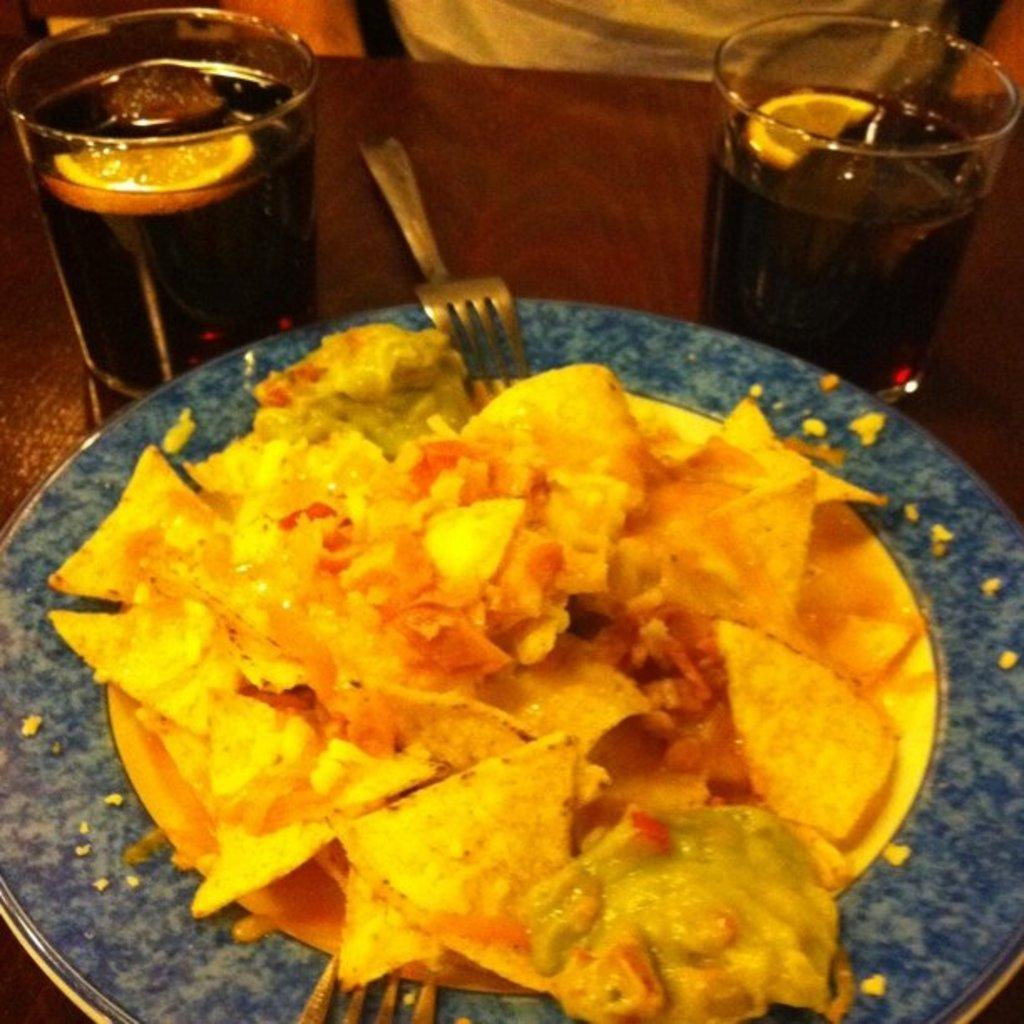What piece of furniture is present in the image? There is a table in the image. What is placed on the table? There is a plate of food on the table. What utensils are available on the table? There are forks, spoons, and knives on the table. What type of beverages are on the table? There are glasses of cool drinks on the table. How does the cook wave at the guests in the image? There is no cook present in the image, and no one is waving at guests. 